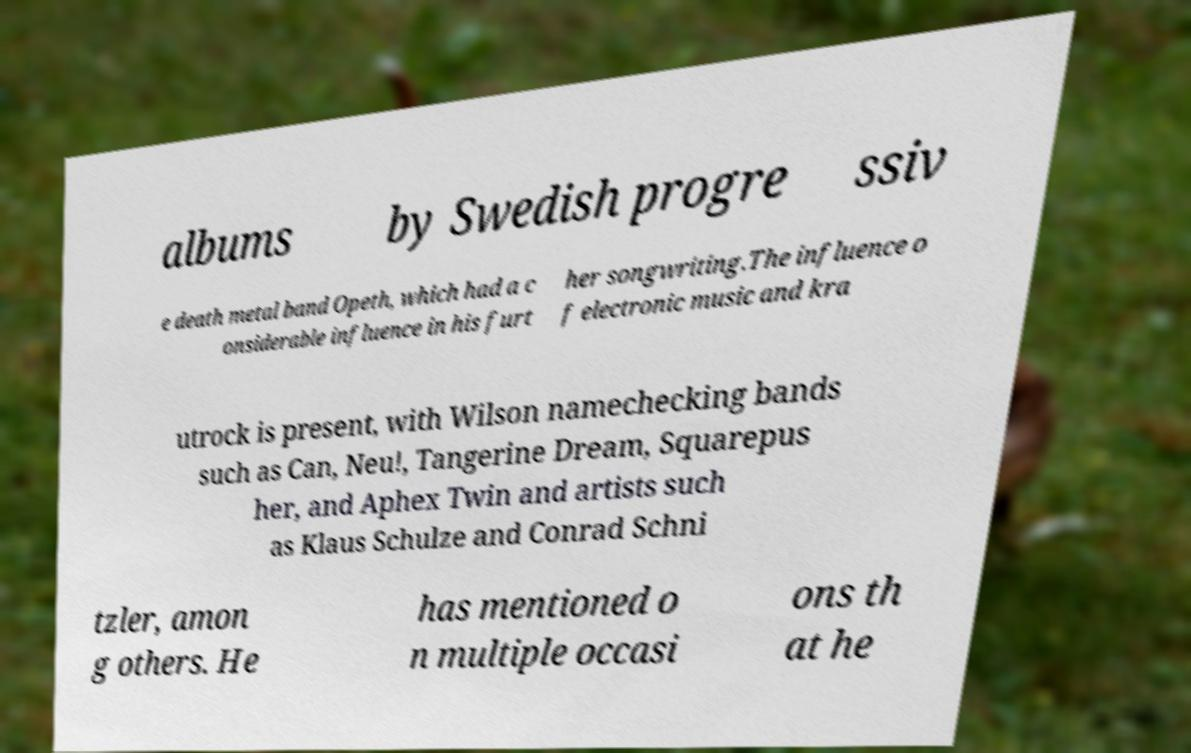I need the written content from this picture converted into text. Can you do that? albums by Swedish progre ssiv e death metal band Opeth, which had a c onsiderable influence in his furt her songwriting.The influence o f electronic music and kra utrock is present, with Wilson namechecking bands such as Can, Neu!, Tangerine Dream, Squarepus her, and Aphex Twin and artists such as Klaus Schulze and Conrad Schni tzler, amon g others. He has mentioned o n multiple occasi ons th at he 